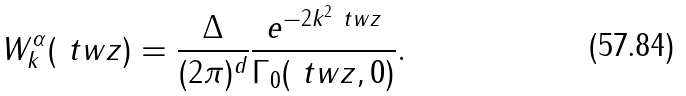<formula> <loc_0><loc_0><loc_500><loc_500>W ^ { \alpha } _ { k } ( \ t w z ) = \frac { \Delta } { ( 2 \pi ) ^ { d } } \frac { e ^ { - 2 k ^ { 2 } \ t w z } } { \Gamma _ { 0 } ( \ t w z , 0 ) } .</formula> 